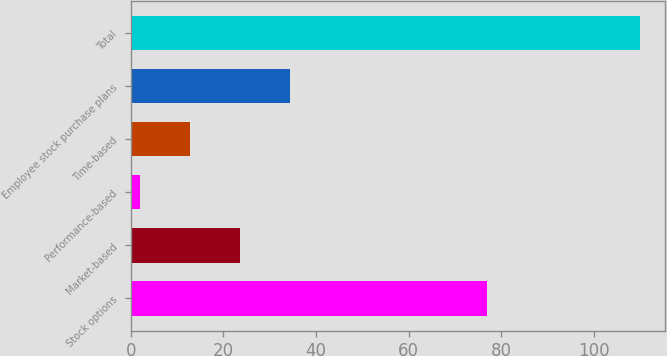Convert chart. <chart><loc_0><loc_0><loc_500><loc_500><bar_chart><fcel>Stock options<fcel>Market-based<fcel>Performance-based<fcel>Time-based<fcel>Employee stock purchase plans<fcel>Total<nl><fcel>77<fcel>23.6<fcel>2<fcel>12.8<fcel>34.4<fcel>110<nl></chart> 